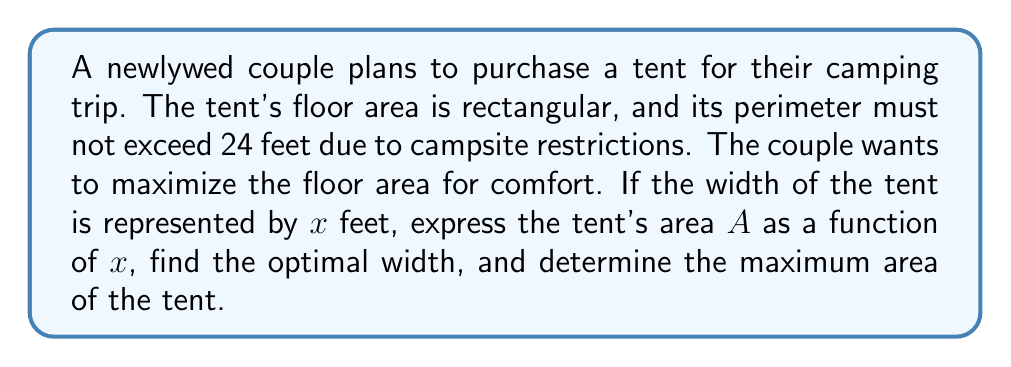What is the answer to this math problem? 1) Let's define our variables:
   $x$ = width of the tent (in feet)
   $y$ = length of the tent (in feet)
   $A$ = area of the tent (in square feet)

2) Given that the perimeter must not exceed 24 feet:
   $2x + 2y = 24$
   Solving for $y$: $y = 12 - x$

3) The area of the tent is given by:
   $A = xy = x(12-x) = 12x - x^2$

4) Therefore, the area as a function of width is:
   $A(x) = -x^2 + 12x$

5) To find the maximum area, we need to find the vertex of this parabola:
   The axis of symmetry is given by $x = -b/(2a)$, where $a$ and $b$ are the coefficients of the quadratic function $ax^2 + bx + c$

   $x = -12/(-2) = 6$

6) The optimal width is 6 feet.

7) To find the maximum area, substitute $x=6$ into the area function:
   $A(6) = -(6)^2 + 12(6) = -36 + 72 = 36$

Therefore, the maximum area is 36 square feet.
Answer: Optimal width: 6 feet; Maximum area: 36 square feet 